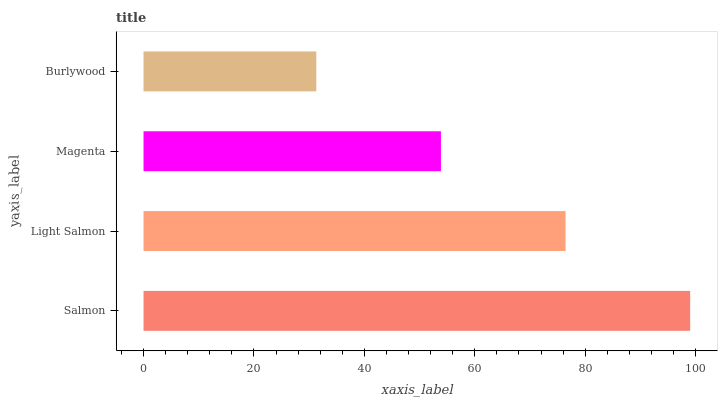Is Burlywood the minimum?
Answer yes or no. Yes. Is Salmon the maximum?
Answer yes or no. Yes. Is Light Salmon the minimum?
Answer yes or no. No. Is Light Salmon the maximum?
Answer yes or no. No. Is Salmon greater than Light Salmon?
Answer yes or no. Yes. Is Light Salmon less than Salmon?
Answer yes or no. Yes. Is Light Salmon greater than Salmon?
Answer yes or no. No. Is Salmon less than Light Salmon?
Answer yes or no. No. Is Light Salmon the high median?
Answer yes or no. Yes. Is Magenta the low median?
Answer yes or no. Yes. Is Magenta the high median?
Answer yes or no. No. Is Light Salmon the low median?
Answer yes or no. No. 